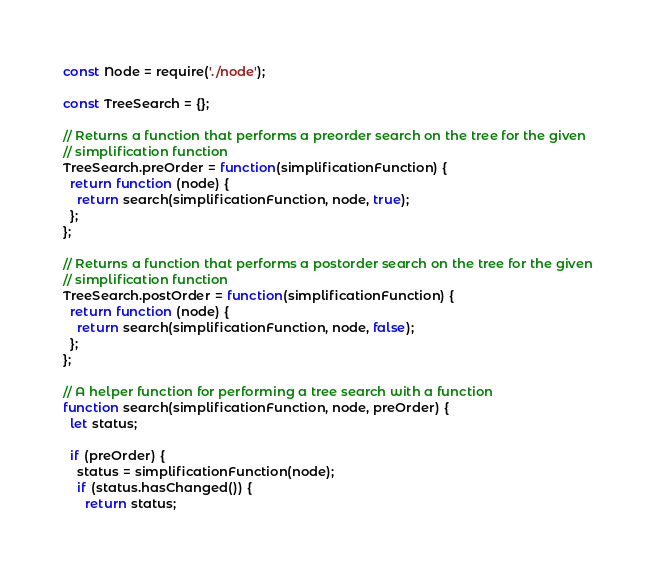<code> <loc_0><loc_0><loc_500><loc_500><_JavaScript_>const Node = require('./node');

const TreeSearch = {};

// Returns a function that performs a preorder search on the tree for the given
// simplification function
TreeSearch.preOrder = function(simplificationFunction) {
  return function (node) {
    return search(simplificationFunction, node, true);
  };
};

// Returns a function that performs a postorder search on the tree for the given
// simplification function
TreeSearch.postOrder = function(simplificationFunction) {
  return function (node) {
    return search(simplificationFunction, node, false);
  };
};

// A helper function for performing a tree search with a function
function search(simplificationFunction, node, preOrder) {
  let status;

  if (preOrder) {
    status = simplificationFunction(node);
    if (status.hasChanged()) {
      return status;</code> 